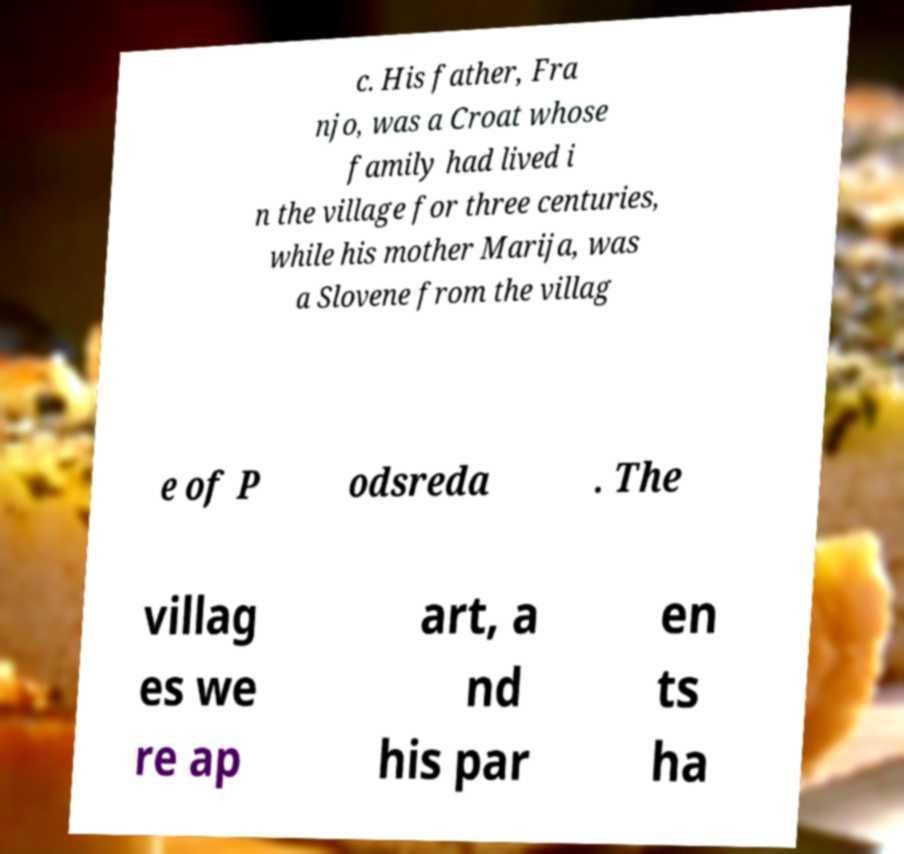Can you read and provide the text displayed in the image?This photo seems to have some interesting text. Can you extract and type it out for me? c. His father, Fra njo, was a Croat whose family had lived i n the village for three centuries, while his mother Marija, was a Slovene from the villag e of P odsreda . The villag es we re ap art, a nd his par en ts ha 